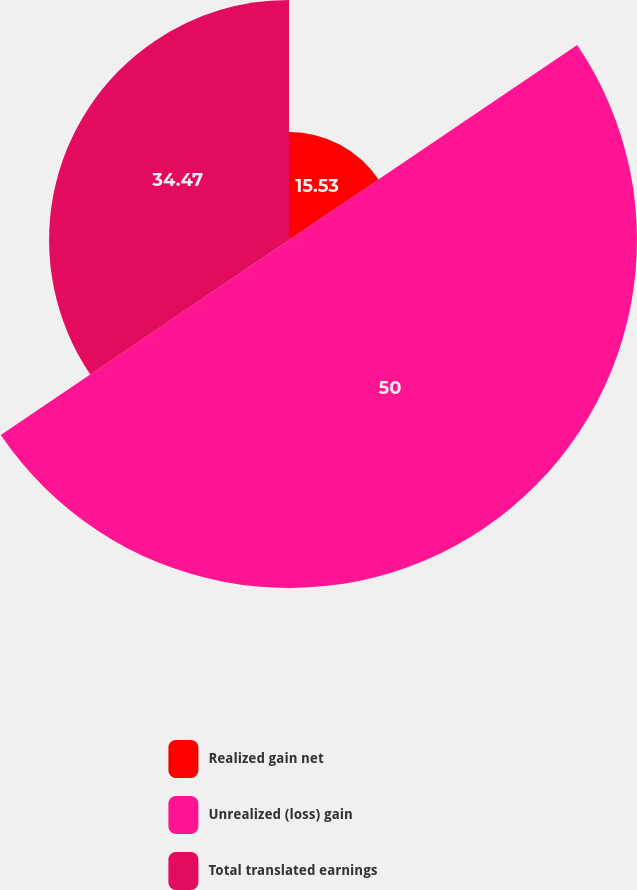Convert chart to OTSL. <chart><loc_0><loc_0><loc_500><loc_500><pie_chart><fcel>Realized gain net<fcel>Unrealized (loss) gain<fcel>Total translated earnings<nl><fcel>15.53%<fcel>50.0%<fcel>34.47%<nl></chart> 